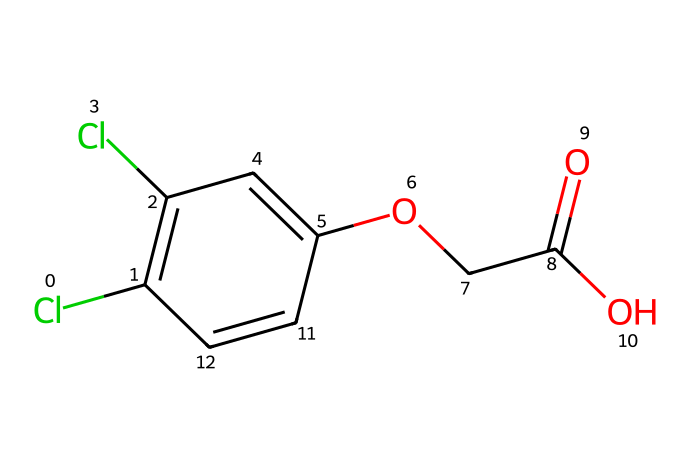How many chlorine atoms are present in the structure? The structure contains two Cl atoms, as indicated by the two 'Cl' notations in the SMILES representation.
Answer: two What functional groups can be identified in 2,4-D? The structure has a carboxylic acid group (-COOH) and an ether group (-O-), identifiable by the carbonyl and hydroxyl features, and a carbon connected to oxygen with another carbon.
Answer: carboxylic acid and ether What is the primary carbon framework of 2,4-D? The major structure is based on a phenoxyacetic acid framework, which includes a benzene ring and acetic acid derivative. This can be deduced from the presence of a phenyl group attached to an acetic acid unit.
Answer: phenoxyacetic acid What type of herbicide is 2,4-D classified as? 2,4-D is a selective herbicide, as it specifically targets broadleaf weeds without harming grasses, a function related to its structural properties.
Answer: selective How many degrees of unsaturation does 2,4-D have? To find the degrees of unsaturation, count rings and double bonds. The structure shows one double bond in the ring and at least one ring, leading to at least three degrees of unsaturation.
Answer: three In what applications is 2,4-D primarily used? 2,4-D is primarily used for controlling broadleaf weeds in various agricultural settings, aligning with its selective herbicide properties.
Answer: agriculture 